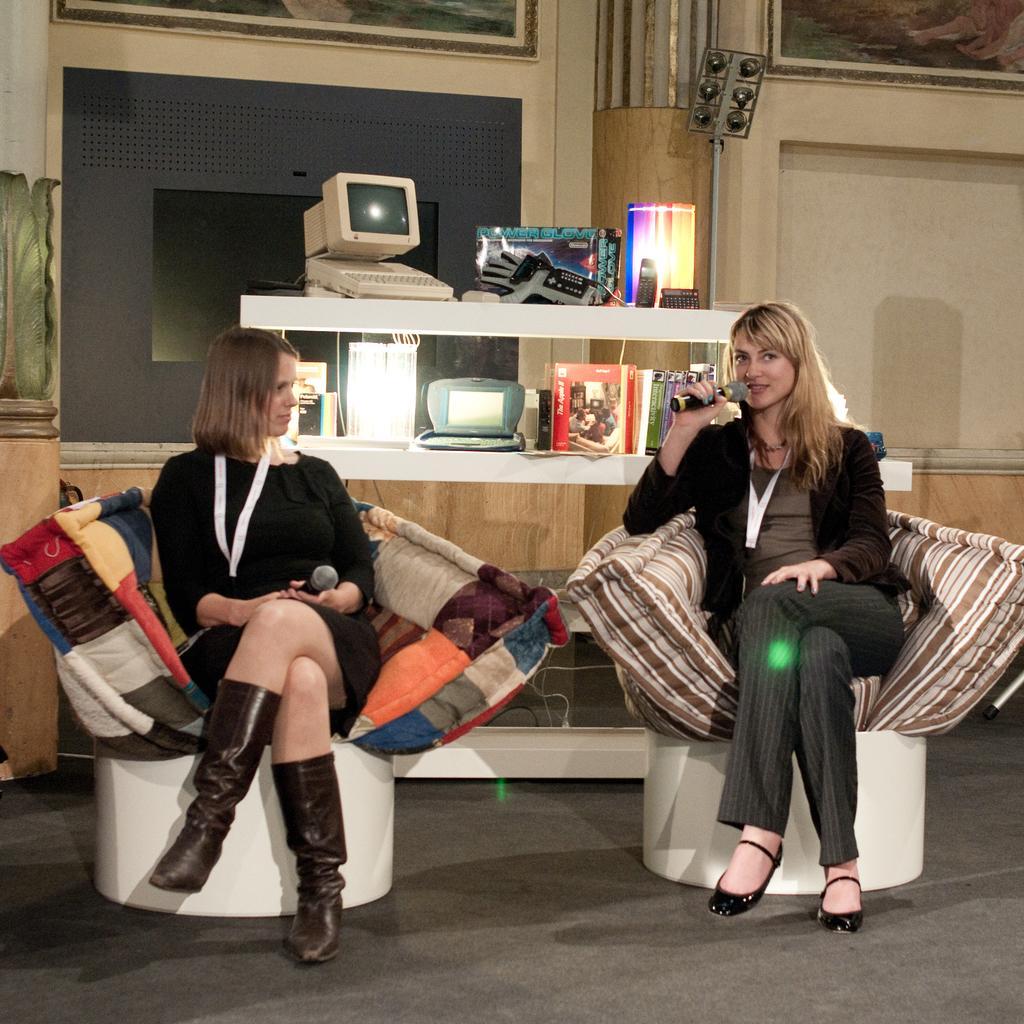Describe this image in one or two sentences. In this image there are two people sitting on the couches and holding a microphone, there is a computer and a few other objects in the shelf's, there are some posters attached to the wall. 